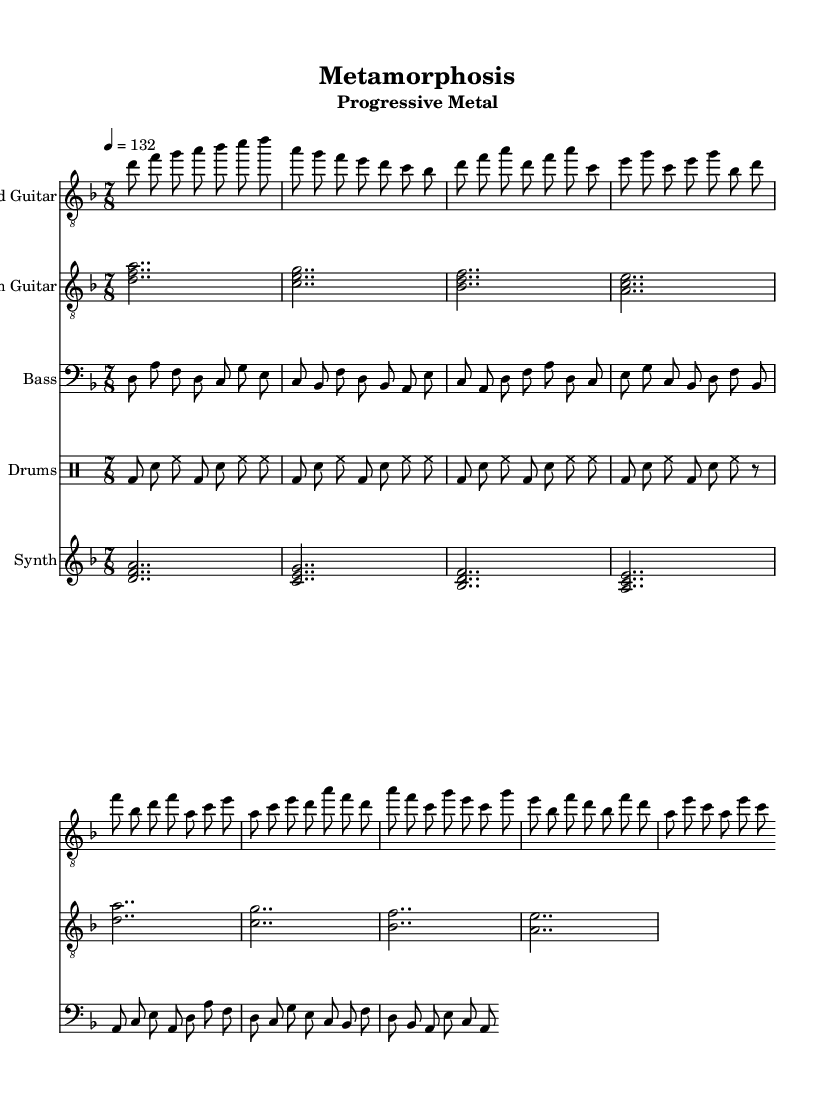What is the key signature of this music? The key signature is D minor, which has one flat (B flat). This can be identified from the globalSettings section where it specifies " \key d \minor".
Answer: D minor What is the time signature of this music? The time signature is 7/8, which is indicated in the globalSettings section with " \time 7/8". This denotes that there are seven eighth notes per measure.
Answer: 7/8 What is the tempo marking for this piece? The tempo marking is 132 beats per minute, as indicated by the " \tempo 4 = 132" statement in the globalSettings.
Answer: 132 What chords are played during the verse? The chords played during the verse are D minor, C major, B flat major, and A minor, which can be seen in the rhythmGuitar section. The chord symbols are presented as their bass note with accompanying notes.
Answer: D minor, C major, B flat major, A minor How many measures are in the chorus? The chorus consists of 4 measures, as evidenced by the structure in the leadGuitar and rhythmGuitar sections where each measure is counted distinctly.
Answer: 4 What instruments are featured in this score? The featured instruments in this score are Lead Guitar, Rhythm Guitar, Bass, Drums, and Synth. This is clear from the score section where each part is assigned to a different staff.
Answer: Lead Guitar, Rhythm Guitar, Bass, Drums, Synth What are the main themes explored in this progressive metal track? The main themes explored in the track are personal growth and self-discovery, as stated in the description prompt and inferred from the complex musical structures and emotional dynamics typical of progressive metal.
Answer: Personal growth, self-discovery 